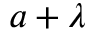Convert formula to latex. <formula><loc_0><loc_0><loc_500><loc_500>a + \lambda</formula> 